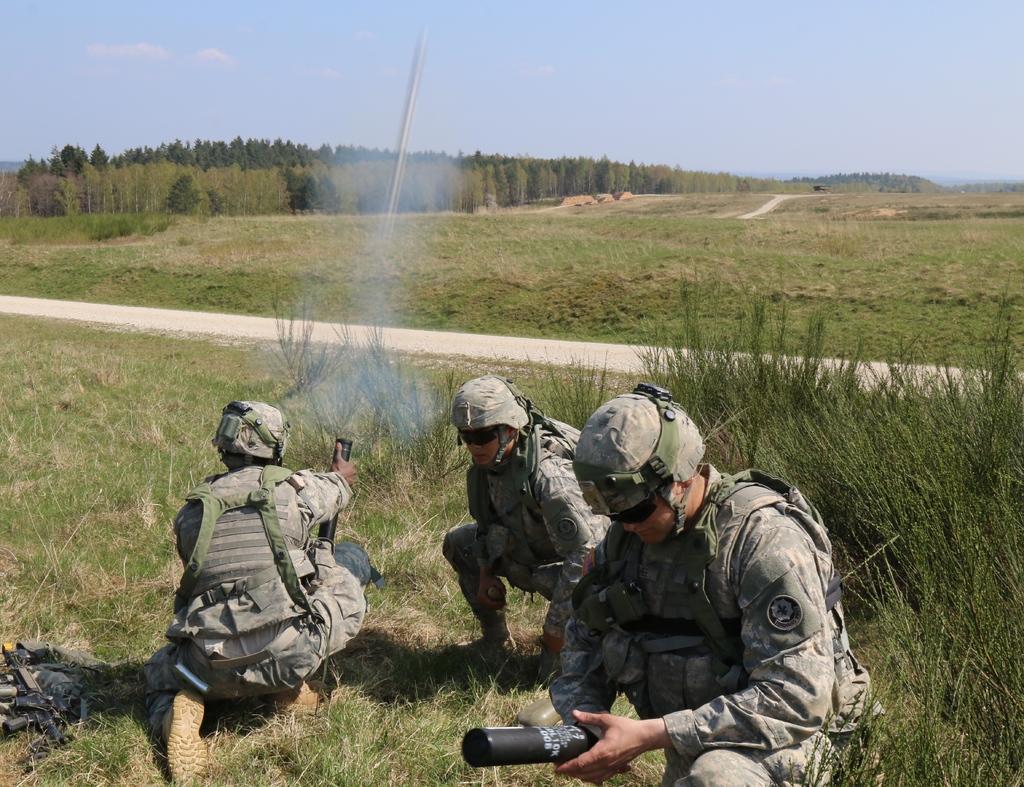In one or two sentences, can you explain what this image depicts? In this image there are three military officers sitting in the grass by holding the missiles. At the top there is the sky. In the background there is a land on which there are trees. In the middle there's a way. 